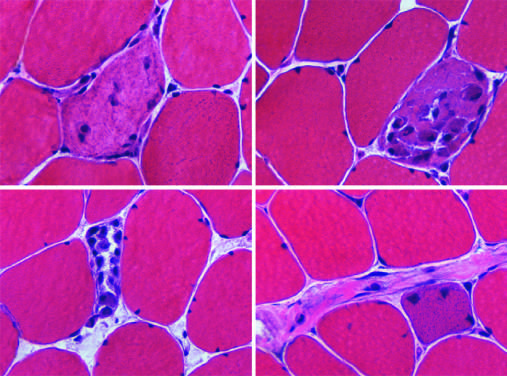re apoptotic cells in colonic epithelium associated with segmental necrosis and regeneration of individual myofibers?
Answer the question using a single word or phrase. No 